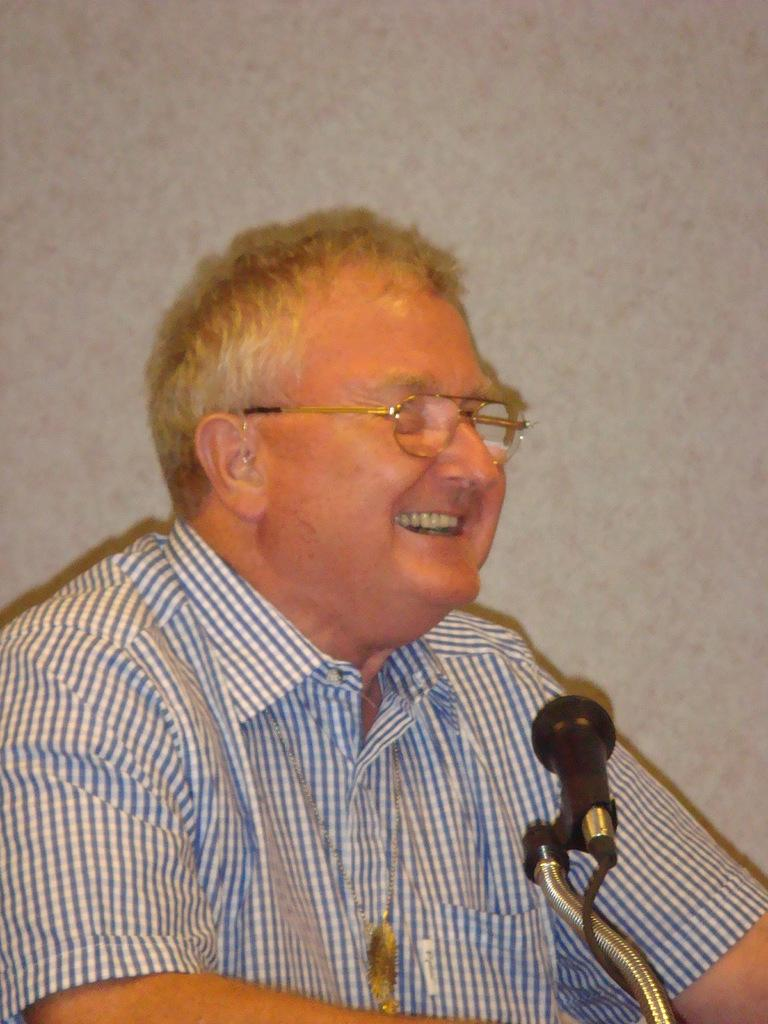Who is present in the image? There is a man in the image. What can be observed about the man's appearance? The man is wearing spectacles and is smiling. What object is in front of the man? There is a microphone with a cable in front of the man. What is visible behind the man? There is a wall behind the man. How many trees can be seen behind the man in the image? There are no trees visible in the image; only a wall is present behind the man. What type of music is the man playing in the image? The image does not provide any information about the man playing music or the type of music being played. 